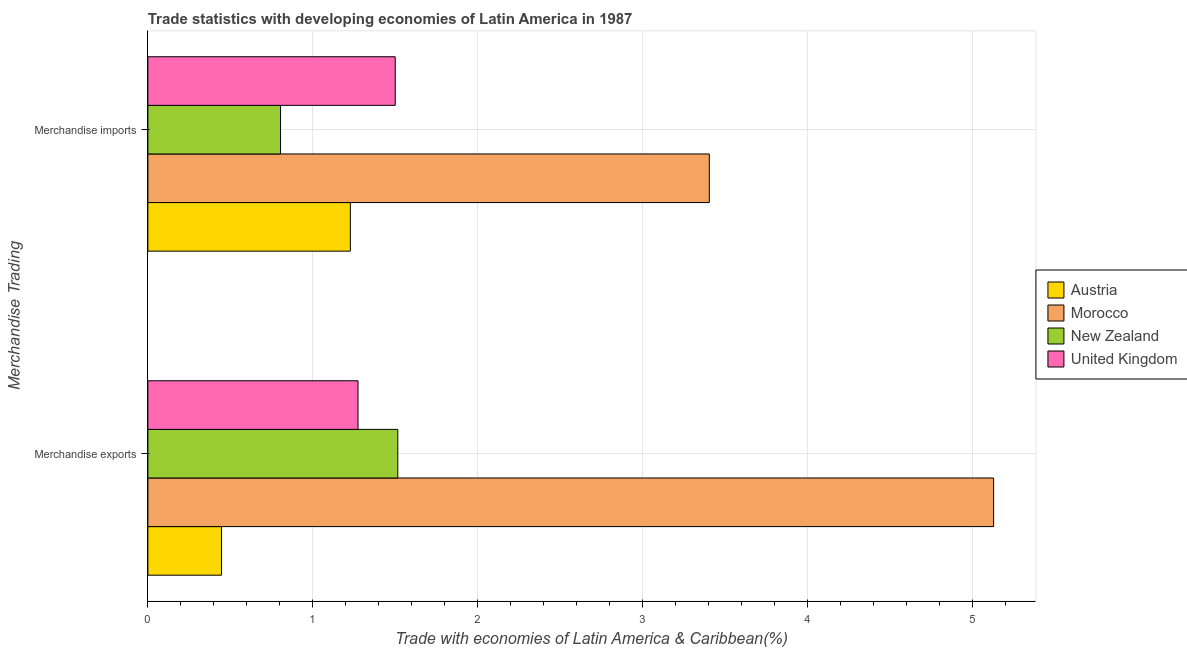How many different coloured bars are there?
Offer a terse response. 4. How many groups of bars are there?
Offer a terse response. 2. What is the merchandise imports in Morocco?
Make the answer very short. 3.4. Across all countries, what is the maximum merchandise imports?
Keep it short and to the point. 3.4. Across all countries, what is the minimum merchandise imports?
Keep it short and to the point. 0.8. In which country was the merchandise imports maximum?
Provide a short and direct response. Morocco. In which country was the merchandise exports minimum?
Provide a succinct answer. Austria. What is the total merchandise imports in the graph?
Your response must be concise. 6.93. What is the difference between the merchandise exports in Austria and that in United Kingdom?
Offer a very short reply. -0.83. What is the difference between the merchandise imports in Austria and the merchandise exports in New Zealand?
Your answer should be compact. -0.29. What is the average merchandise imports per country?
Provide a succinct answer. 1.73. What is the difference between the merchandise exports and merchandise imports in New Zealand?
Provide a short and direct response. 0.71. In how many countries, is the merchandise exports greater than 0.6000000000000001 %?
Offer a very short reply. 3. What is the ratio of the merchandise imports in Morocco to that in United Kingdom?
Provide a succinct answer. 2.27. What does the 3rd bar from the top in Merchandise imports represents?
Keep it short and to the point. Morocco. How many bars are there?
Your answer should be very brief. 8. Are the values on the major ticks of X-axis written in scientific E-notation?
Give a very brief answer. No. Does the graph contain any zero values?
Provide a short and direct response. No. Does the graph contain grids?
Give a very brief answer. Yes. How are the legend labels stacked?
Keep it short and to the point. Vertical. What is the title of the graph?
Ensure brevity in your answer.  Trade statistics with developing economies of Latin America in 1987. Does "Middle East & North Africa (all income levels)" appear as one of the legend labels in the graph?
Your answer should be compact. No. What is the label or title of the X-axis?
Offer a very short reply. Trade with economies of Latin America & Caribbean(%). What is the label or title of the Y-axis?
Your answer should be very brief. Merchandise Trading. What is the Trade with economies of Latin America & Caribbean(%) in Austria in Merchandise exports?
Keep it short and to the point. 0.45. What is the Trade with economies of Latin America & Caribbean(%) of Morocco in Merchandise exports?
Give a very brief answer. 5.13. What is the Trade with economies of Latin America & Caribbean(%) in New Zealand in Merchandise exports?
Your answer should be compact. 1.51. What is the Trade with economies of Latin America & Caribbean(%) in United Kingdom in Merchandise exports?
Your response must be concise. 1.27. What is the Trade with economies of Latin America & Caribbean(%) in Austria in Merchandise imports?
Your response must be concise. 1.23. What is the Trade with economies of Latin America & Caribbean(%) in Morocco in Merchandise imports?
Offer a terse response. 3.4. What is the Trade with economies of Latin America & Caribbean(%) in New Zealand in Merchandise imports?
Your answer should be very brief. 0.8. What is the Trade with economies of Latin America & Caribbean(%) of United Kingdom in Merchandise imports?
Your answer should be compact. 1.5. Across all Merchandise Trading, what is the maximum Trade with economies of Latin America & Caribbean(%) of Austria?
Offer a very short reply. 1.23. Across all Merchandise Trading, what is the maximum Trade with economies of Latin America & Caribbean(%) of Morocco?
Make the answer very short. 5.13. Across all Merchandise Trading, what is the maximum Trade with economies of Latin America & Caribbean(%) of New Zealand?
Give a very brief answer. 1.51. Across all Merchandise Trading, what is the maximum Trade with economies of Latin America & Caribbean(%) of United Kingdom?
Your answer should be compact. 1.5. Across all Merchandise Trading, what is the minimum Trade with economies of Latin America & Caribbean(%) of Austria?
Keep it short and to the point. 0.45. Across all Merchandise Trading, what is the minimum Trade with economies of Latin America & Caribbean(%) in Morocco?
Keep it short and to the point. 3.4. Across all Merchandise Trading, what is the minimum Trade with economies of Latin America & Caribbean(%) in New Zealand?
Make the answer very short. 0.8. Across all Merchandise Trading, what is the minimum Trade with economies of Latin America & Caribbean(%) of United Kingdom?
Make the answer very short. 1.27. What is the total Trade with economies of Latin America & Caribbean(%) of Austria in the graph?
Offer a very short reply. 1.67. What is the total Trade with economies of Latin America & Caribbean(%) in Morocco in the graph?
Your answer should be very brief. 8.53. What is the total Trade with economies of Latin America & Caribbean(%) in New Zealand in the graph?
Ensure brevity in your answer.  2.32. What is the total Trade with economies of Latin America & Caribbean(%) in United Kingdom in the graph?
Your answer should be very brief. 2.77. What is the difference between the Trade with economies of Latin America & Caribbean(%) in Austria in Merchandise exports and that in Merchandise imports?
Ensure brevity in your answer.  -0.78. What is the difference between the Trade with economies of Latin America & Caribbean(%) of Morocco in Merchandise exports and that in Merchandise imports?
Offer a very short reply. 1.72. What is the difference between the Trade with economies of Latin America & Caribbean(%) of New Zealand in Merchandise exports and that in Merchandise imports?
Keep it short and to the point. 0.71. What is the difference between the Trade with economies of Latin America & Caribbean(%) in United Kingdom in Merchandise exports and that in Merchandise imports?
Make the answer very short. -0.23. What is the difference between the Trade with economies of Latin America & Caribbean(%) in Austria in Merchandise exports and the Trade with economies of Latin America & Caribbean(%) in Morocco in Merchandise imports?
Make the answer very short. -2.96. What is the difference between the Trade with economies of Latin America & Caribbean(%) in Austria in Merchandise exports and the Trade with economies of Latin America & Caribbean(%) in New Zealand in Merchandise imports?
Offer a terse response. -0.36. What is the difference between the Trade with economies of Latin America & Caribbean(%) of Austria in Merchandise exports and the Trade with economies of Latin America & Caribbean(%) of United Kingdom in Merchandise imports?
Provide a short and direct response. -1.05. What is the difference between the Trade with economies of Latin America & Caribbean(%) in Morocco in Merchandise exports and the Trade with economies of Latin America & Caribbean(%) in New Zealand in Merchandise imports?
Your response must be concise. 4.32. What is the difference between the Trade with economies of Latin America & Caribbean(%) in Morocco in Merchandise exports and the Trade with economies of Latin America & Caribbean(%) in United Kingdom in Merchandise imports?
Your answer should be compact. 3.63. What is the difference between the Trade with economies of Latin America & Caribbean(%) in New Zealand in Merchandise exports and the Trade with economies of Latin America & Caribbean(%) in United Kingdom in Merchandise imports?
Your response must be concise. 0.02. What is the average Trade with economies of Latin America & Caribbean(%) in Austria per Merchandise Trading?
Make the answer very short. 0.84. What is the average Trade with economies of Latin America & Caribbean(%) in Morocco per Merchandise Trading?
Offer a very short reply. 4.26. What is the average Trade with economies of Latin America & Caribbean(%) in New Zealand per Merchandise Trading?
Your answer should be compact. 1.16. What is the average Trade with economies of Latin America & Caribbean(%) of United Kingdom per Merchandise Trading?
Provide a short and direct response. 1.39. What is the difference between the Trade with economies of Latin America & Caribbean(%) in Austria and Trade with economies of Latin America & Caribbean(%) in Morocco in Merchandise exports?
Your response must be concise. -4.68. What is the difference between the Trade with economies of Latin America & Caribbean(%) in Austria and Trade with economies of Latin America & Caribbean(%) in New Zealand in Merchandise exports?
Your answer should be very brief. -1.07. What is the difference between the Trade with economies of Latin America & Caribbean(%) of Austria and Trade with economies of Latin America & Caribbean(%) of United Kingdom in Merchandise exports?
Make the answer very short. -0.83. What is the difference between the Trade with economies of Latin America & Caribbean(%) in Morocco and Trade with economies of Latin America & Caribbean(%) in New Zealand in Merchandise exports?
Keep it short and to the point. 3.61. What is the difference between the Trade with economies of Latin America & Caribbean(%) in Morocco and Trade with economies of Latin America & Caribbean(%) in United Kingdom in Merchandise exports?
Your answer should be very brief. 3.85. What is the difference between the Trade with economies of Latin America & Caribbean(%) of New Zealand and Trade with economies of Latin America & Caribbean(%) of United Kingdom in Merchandise exports?
Your response must be concise. 0.24. What is the difference between the Trade with economies of Latin America & Caribbean(%) in Austria and Trade with economies of Latin America & Caribbean(%) in Morocco in Merchandise imports?
Your answer should be compact. -2.18. What is the difference between the Trade with economies of Latin America & Caribbean(%) of Austria and Trade with economies of Latin America & Caribbean(%) of New Zealand in Merchandise imports?
Provide a succinct answer. 0.42. What is the difference between the Trade with economies of Latin America & Caribbean(%) in Austria and Trade with economies of Latin America & Caribbean(%) in United Kingdom in Merchandise imports?
Your answer should be compact. -0.27. What is the difference between the Trade with economies of Latin America & Caribbean(%) of Morocco and Trade with economies of Latin America & Caribbean(%) of New Zealand in Merchandise imports?
Offer a terse response. 2.6. What is the difference between the Trade with economies of Latin America & Caribbean(%) in Morocco and Trade with economies of Latin America & Caribbean(%) in United Kingdom in Merchandise imports?
Your response must be concise. 1.9. What is the difference between the Trade with economies of Latin America & Caribbean(%) in New Zealand and Trade with economies of Latin America & Caribbean(%) in United Kingdom in Merchandise imports?
Provide a succinct answer. -0.7. What is the ratio of the Trade with economies of Latin America & Caribbean(%) of Austria in Merchandise exports to that in Merchandise imports?
Offer a terse response. 0.36. What is the ratio of the Trade with economies of Latin America & Caribbean(%) of Morocco in Merchandise exports to that in Merchandise imports?
Ensure brevity in your answer.  1.51. What is the ratio of the Trade with economies of Latin America & Caribbean(%) of New Zealand in Merchandise exports to that in Merchandise imports?
Offer a terse response. 1.88. What is the ratio of the Trade with economies of Latin America & Caribbean(%) of United Kingdom in Merchandise exports to that in Merchandise imports?
Provide a short and direct response. 0.85. What is the difference between the highest and the second highest Trade with economies of Latin America & Caribbean(%) in Austria?
Offer a terse response. 0.78. What is the difference between the highest and the second highest Trade with economies of Latin America & Caribbean(%) in Morocco?
Provide a short and direct response. 1.72. What is the difference between the highest and the second highest Trade with economies of Latin America & Caribbean(%) of New Zealand?
Provide a succinct answer. 0.71. What is the difference between the highest and the second highest Trade with economies of Latin America & Caribbean(%) in United Kingdom?
Your answer should be compact. 0.23. What is the difference between the highest and the lowest Trade with economies of Latin America & Caribbean(%) in Austria?
Keep it short and to the point. 0.78. What is the difference between the highest and the lowest Trade with economies of Latin America & Caribbean(%) in Morocco?
Offer a very short reply. 1.72. What is the difference between the highest and the lowest Trade with economies of Latin America & Caribbean(%) in New Zealand?
Your response must be concise. 0.71. What is the difference between the highest and the lowest Trade with economies of Latin America & Caribbean(%) of United Kingdom?
Give a very brief answer. 0.23. 